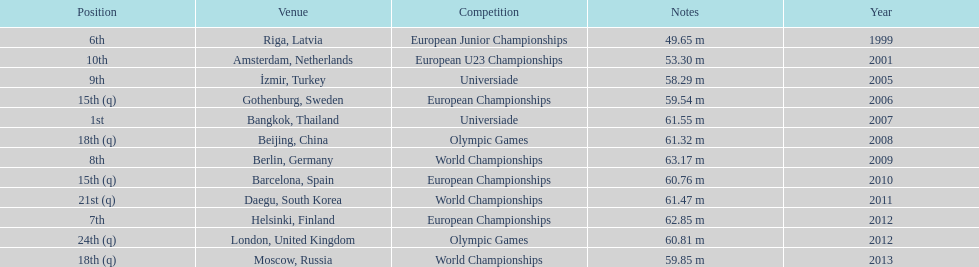Prior to 2007, what was the highest place achieved? 6th. Parse the table in full. {'header': ['Position', 'Venue', 'Competition', 'Notes', 'Year'], 'rows': [['6th', 'Riga, Latvia', 'European Junior Championships', '49.65 m', '1999'], ['10th', 'Amsterdam, Netherlands', 'European U23 Championships', '53.30 m', '2001'], ['9th', 'İzmir, Turkey', 'Universiade', '58.29 m', '2005'], ['15th (q)', 'Gothenburg, Sweden', 'European Championships', '59.54 m', '2006'], ['1st', 'Bangkok, Thailand', 'Universiade', '61.55 m', '2007'], ['18th (q)', 'Beijing, China', 'Olympic Games', '61.32 m', '2008'], ['8th', 'Berlin, Germany', 'World Championships', '63.17 m', '2009'], ['15th (q)', 'Barcelona, Spain', 'European Championships', '60.76 m', '2010'], ['21st (q)', 'Daegu, South Korea', 'World Championships', '61.47 m', '2011'], ['7th', 'Helsinki, Finland', 'European Championships', '62.85 m', '2012'], ['24th (q)', 'London, United Kingdom', 'Olympic Games', '60.81 m', '2012'], ['18th (q)', 'Moscow, Russia', 'World Championships', '59.85 m', '2013']]} 